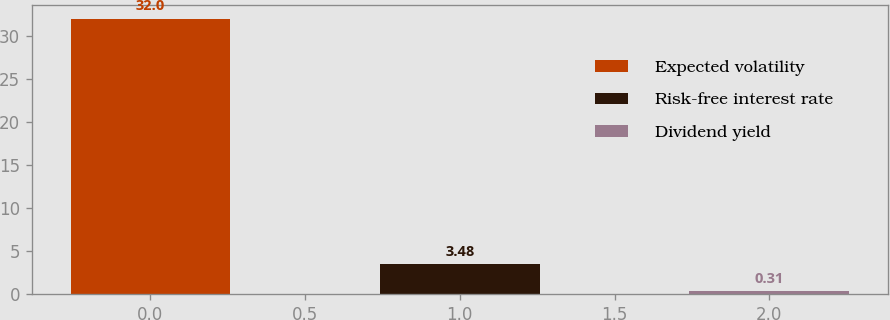Convert chart to OTSL. <chart><loc_0><loc_0><loc_500><loc_500><bar_chart><fcel>Expected volatility<fcel>Risk-free interest rate<fcel>Dividend yield<nl><fcel>32<fcel>3.48<fcel>0.31<nl></chart> 